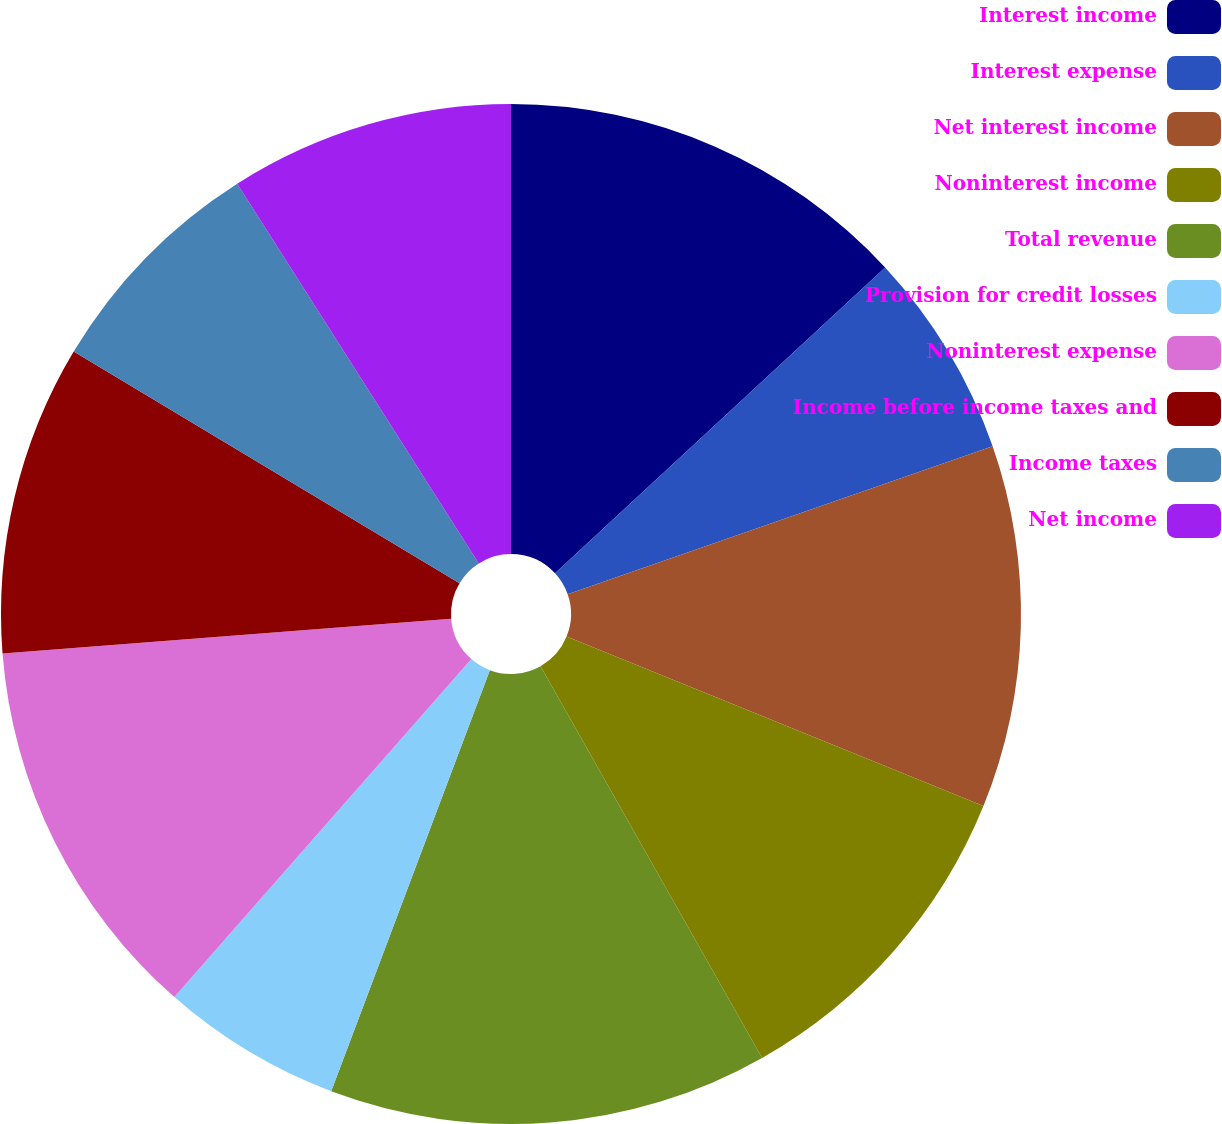Convert chart. <chart><loc_0><loc_0><loc_500><loc_500><pie_chart><fcel>Interest income<fcel>Interest expense<fcel>Net interest income<fcel>Noninterest income<fcel>Total revenue<fcel>Provision for credit losses<fcel>Noninterest expense<fcel>Income before income taxes and<fcel>Income taxes<fcel>Net income<nl><fcel>13.11%<fcel>6.56%<fcel>11.48%<fcel>10.66%<fcel>13.93%<fcel>5.74%<fcel>12.29%<fcel>9.84%<fcel>7.38%<fcel>9.02%<nl></chart> 